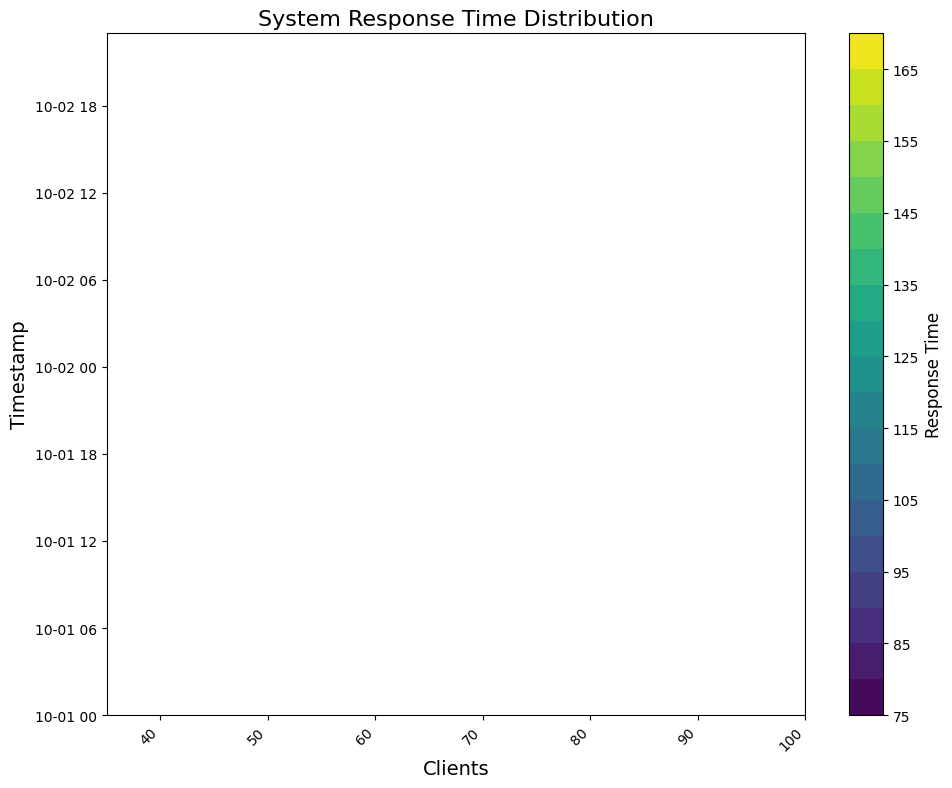What's the range of response times for a client load of 80? First, identify the timestamps where the number of clients is 80. Then, observe the colors in the contour indicating the response times, noting the minimum and maximum values.
Answer: 87-135 During what period does the response time exceed 150 ms for any client load? Look at the timestamps across the x-axis and identify the durations where the color corresponding to over 150 ms (usually a darker shade) is present.
Answer: 10:00 to 12:00 on 2023-10-01 and 18:00 to 20:00 on 2023-10-02 Is the response time generally higher during the early morning or late evening? Compare the response times (color tones) for the early morning hours (00:00 - 06:00) with those in the late evening (18:00 - 23:00/24:00).
Answer: Late evening What is the average response time during peak (highest) client load? Identify data points where the client load is maximum, find the corresponding response times and calculate their average. Client load peaks at 100 clients typically, and the associated response times are observed.
Answer: 160 ms What period shows the highest variation in response time? Look for the timestamp range where the contour lines are most spaced out, indicating high variation. This generally means wider intervals between minimum and maximum response times.
Answer: 10:00 to 12:00 on 2023-10-01 When is the response time lowest for a client load of 65? Locate the timestamps when the client load is 65 and look for the lightest shade indicating the minimum response time.
Answer: 20:00 on 2023-10-01 Compare the response times at 08:00 on both days, which day has a lower response time? Identify both 08:00 timestamps on the contour, compare their corresponding colors, the lighter shade indicates lower response time.
Answer: 2023-10-02 What is the overall trend in response times as client load increases? Observe the contour plot across different client loads, and describe the general pattern in response times (color changes from lighter to darker shades as client load increases).
Answer: Response time increases Identify two points on the plot where the response time is similar despite different client loads. Look for areas where color changes are similar but occur at different client counts, visually matching shades for accurate comparison.
Answer: 20:00 on 2023-10-01 (65 clients) and 08:00 on 2023-10-02 (60 clients), both around 90 ms How does the midday response time at 12:00 compare to the evening response time at 20:00? Identify and compare the response times by observing the colors at 12:00 and 20:00 across the contour plot.
Answer: Midday is higher 